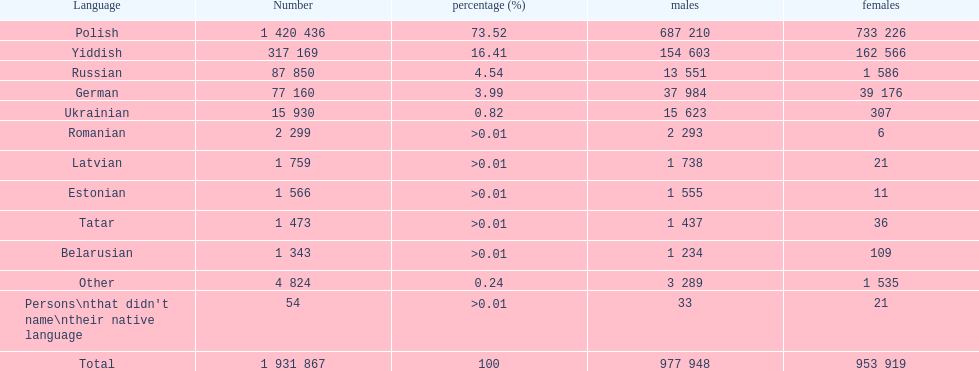The least amount of females Romanian. Parse the full table. {'header': ['Language', 'Number', 'percentage (%)', 'males', 'females'], 'rows': [['Polish', '1 420 436', '73.52', '687 210', '733 226'], ['Yiddish', '317 169', '16.41', '154 603', '162 566'], ['Russian', '87 850', '4.54', '13 551', '1 586'], ['German', '77 160', '3.99', '37 984', '39 176'], ['Ukrainian', '15 930', '0.82', '15 623', '307'], ['Romanian', '2 299', '>0.01', '2 293', '6'], ['Latvian', '1 759', '>0.01', '1 738', '21'], ['Estonian', '1 566', '>0.01', '1 555', '11'], ['Tatar', '1 473', '>0.01', '1 437', '36'], ['Belarusian', '1 343', '>0.01', '1 234', '109'], ['Other', '4 824', '0.24', '3 289', '1 535'], ["Persons\\nthat didn't name\\ntheir native language", '54', '>0.01', '33', '21'], ['Total', '1 931 867', '100', '977 948', '953 919']]} 